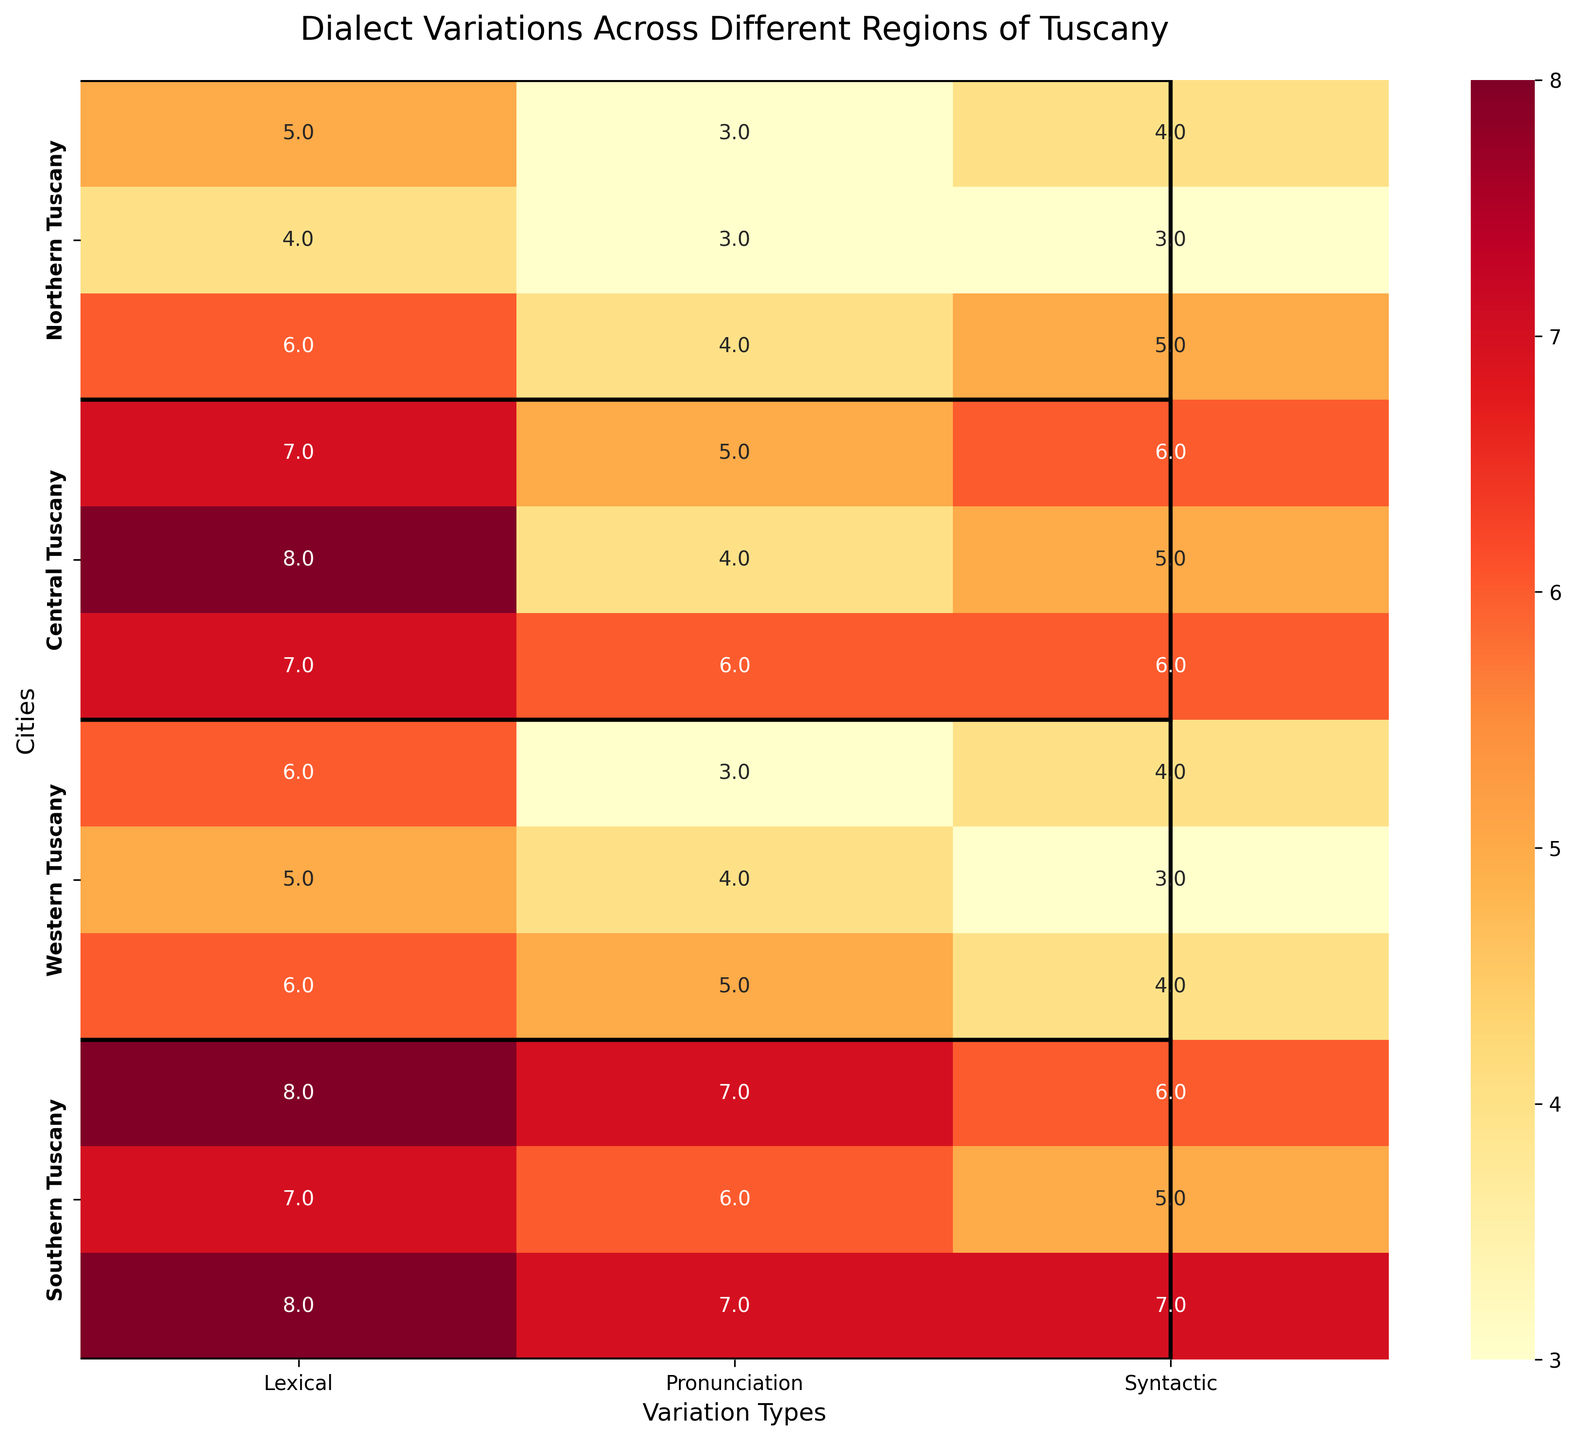How many cities are represented in the heatmap? Count the number of cities listed along the y-axis. There are twelve distinct city names listed vertically.
Answer: 12 Which city in Western Tuscany has the highest lexical variation? Identify the cities under "Western Tuscany" and compare their lexical variation values. Viareggio has the highest lexical variation score of 6.
Answer: Viareggio What is the average pronunciation variation score for cities in Southern Tuscany? Add up the pronunciation variation scores for Grosseto, Orbetello, and Porto Santo Stefano (7 + 6 + 7) and then divide by the number of cities (3). (7 + 6 + 7)/3 = 20/3 = 6.67
Answer: 6.67 Which region has the city with the highest syntactic variation? Look for the highest value in the syntactic variation column and note which city and region it belongs to. Porto Santo Stefano in Southern Tuscany has the highest syntactic variation score of 7.
Answer: Southern Tuscany Which city in Central Tuscany has the lowest lexical variation? Identify the cities in Central Tuscany and compare their lexical variation values. Arezzo has the lowest lexical variation score of 7.
Answer: Arezzo What is the difference in pronunciation variation between Florence and Pistoia? Subtract the pronunciation variation score of Florence (3) from that of Pistoia (4). 4 - 3 = 1
Answer: 1 Compare the syntactic variation scores for Pisa and Lucca. Which one is higher? Compare the syntactic variation values for Pisa (4) and Lucca (3). Pisa's score is higher.
Answer: Pisa Which cities have the same lexical variation score of 6? Look through the lexical variation column and note which cities have the value of 6. Pistoia, Pisa, Viareggio.
Answer: Pistoia, Pisa, Viareggio What is the total lexical variation for all cities in Northern Tuscany? Sum the lexical variation scores for Florence, Prato, and Pistoia (5 + 4 + 6). 5 + 4 + 6 = 15
Answer: 15 How does the lexical variation of Montepulciano compare to Orbetello? Compare the lexical variation scores of Montepulciano (7) and Orbetello (7). Both cities have the same score.
Answer: Equal 